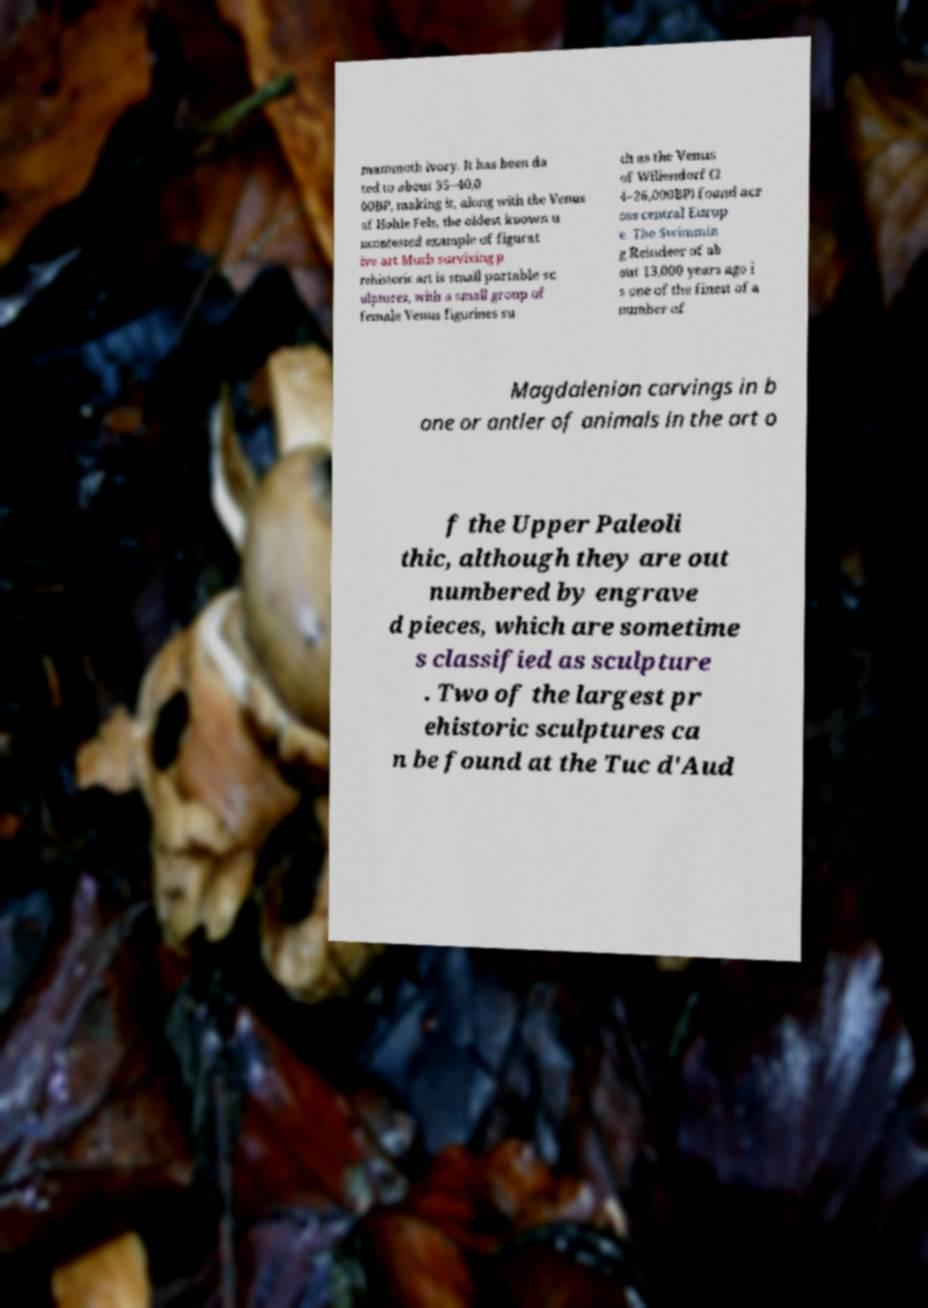Can you accurately transcribe the text from the provided image for me? mammoth ivory. It has been da ted to about 35–40,0 00BP, making it, along with the Venus of Hohle Fels, the oldest known u ncontested example of figurat ive art.Much surviving p rehistoric art is small portable sc ulptures, with a small group of female Venus figurines su ch as the Venus of Willendorf (2 4–26,000BP) found acr oss central Europ e. The Swimmin g Reindeer of ab out 13,000 years ago i s one of the finest of a number of Magdalenian carvings in b one or antler of animals in the art o f the Upper Paleoli thic, although they are out numbered by engrave d pieces, which are sometime s classified as sculpture . Two of the largest pr ehistoric sculptures ca n be found at the Tuc d'Aud 